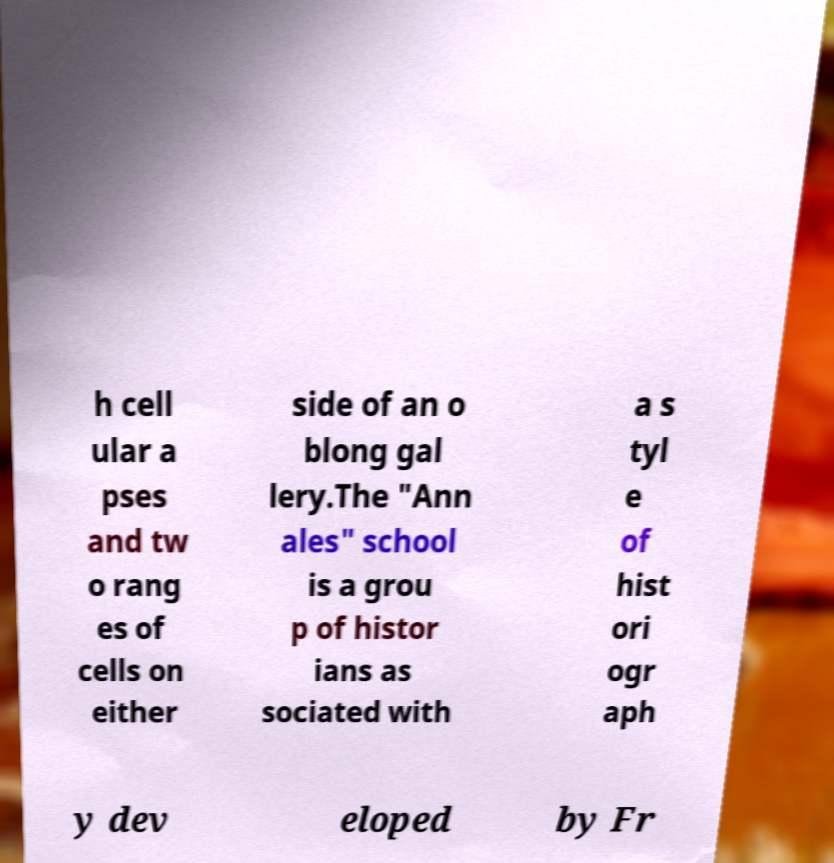Can you accurately transcribe the text from the provided image for me? h cell ular a pses and tw o rang es of cells on either side of an o blong gal lery.The "Ann ales" school is a grou p of histor ians as sociated with a s tyl e of hist ori ogr aph y dev eloped by Fr 